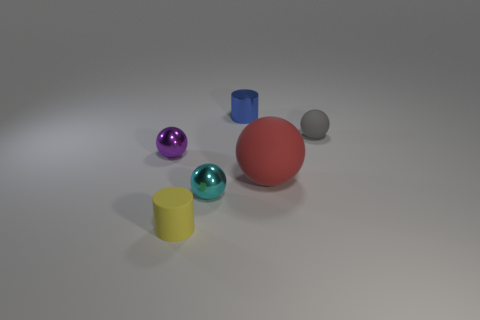Is the sphere to the right of the large rubber sphere made of the same material as the cylinder that is on the left side of the blue metal cylinder?
Provide a short and direct response. Yes. What is the shape of the yellow rubber object that is the same size as the gray sphere?
Provide a short and direct response. Cylinder. What number of yellow objects are spheres or tiny matte cylinders?
Make the answer very short. 1. There is a tiny shiny object on the left side of the tiny yellow matte cylinder; is its shape the same as the tiny matte thing that is to the right of the tiny blue object?
Provide a succinct answer. Yes. How many other things are there of the same material as the gray thing?
Your answer should be very brief. 2. There is a purple metallic object that is in front of the shiny object that is on the right side of the cyan object; is there a cylinder that is behind it?
Offer a very short reply. Yes. Does the gray ball have the same material as the big red sphere?
Provide a succinct answer. Yes. The tiny cylinder that is on the right side of the tiny matte object that is in front of the small gray ball is made of what material?
Give a very brief answer. Metal. What is the size of the red thing in front of the blue metallic cylinder?
Keep it short and to the point. Large. What color is the matte object that is both in front of the gray rubber sphere and behind the yellow matte object?
Keep it short and to the point. Red. 